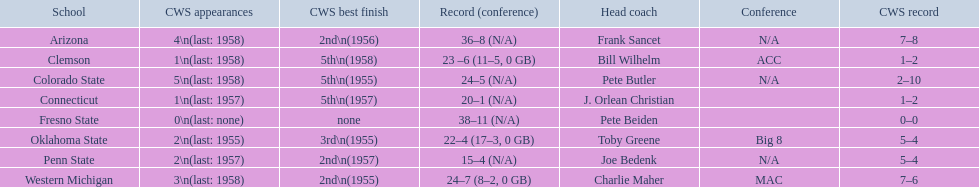What were scores for each school in the 1959 ncaa tournament? 36–8 (N/A), 23 –6 (11–5, 0 GB), 24–5 (N/A), 20–1 (N/A), 38–11 (N/A), 22–4 (17–3, 0 GB), 15–4 (N/A), 24–7 (8–2, 0 GB). What score did not have at least 16 wins? 15–4 (N/A). What team earned this score? Penn State. 